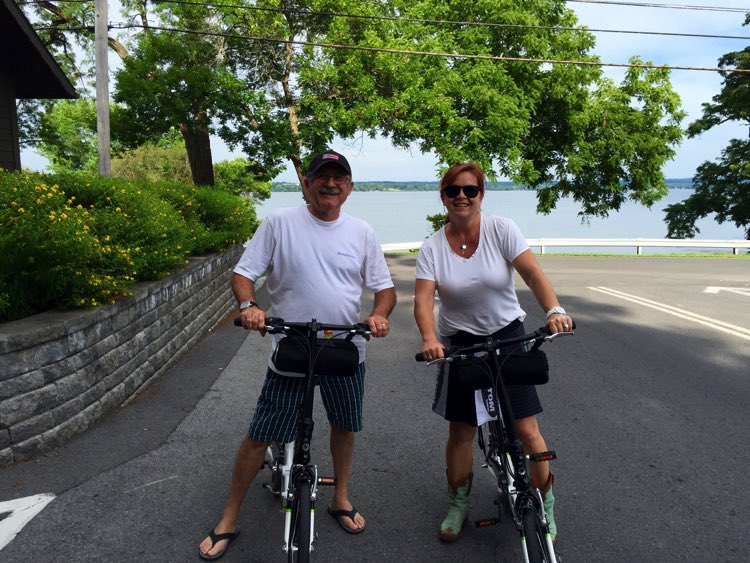Considering the design and features of the bicycles, what type of cycling activity do they seem to be engaged in? Based on the design and features of the bicycles, which have upright handlebars, comfortable seats, and a general leisure design without any specialized equipment, it seems that the individuals are engaged in casual, recreational cycling. The bicycles are not designed for high-speed or competitive cycling, nor do they have the rugged features of mountain bikes. Instead, they appear to be designed for comfort and stability, ideal for a leisurely ride on paved roads in scenic areas. 